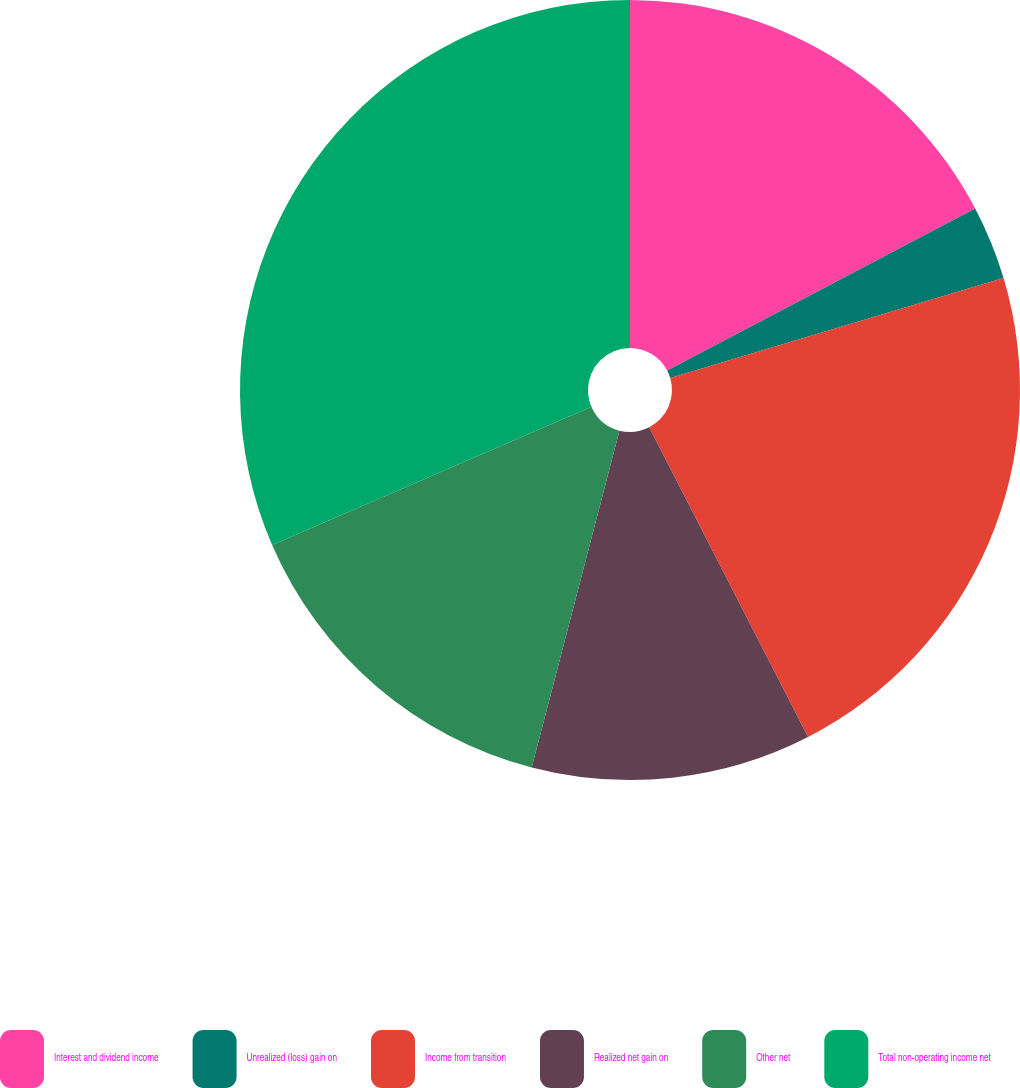<chart> <loc_0><loc_0><loc_500><loc_500><pie_chart><fcel>Interest and dividend income<fcel>Unrealized (loss) gain on<fcel>Income from transition<fcel>Realized net gain on<fcel>Other net<fcel>Total non-operating income net<nl><fcel>17.29%<fcel>3.07%<fcel>22.09%<fcel>11.6%<fcel>14.44%<fcel>31.5%<nl></chart> 